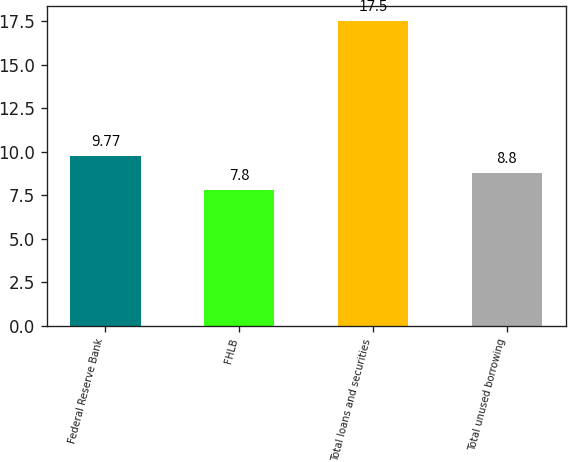<chart> <loc_0><loc_0><loc_500><loc_500><bar_chart><fcel>Federal Reserve Bank<fcel>FHLB<fcel>Total loans and securities<fcel>Total unused borrowing<nl><fcel>9.77<fcel>7.8<fcel>17.5<fcel>8.8<nl></chart> 